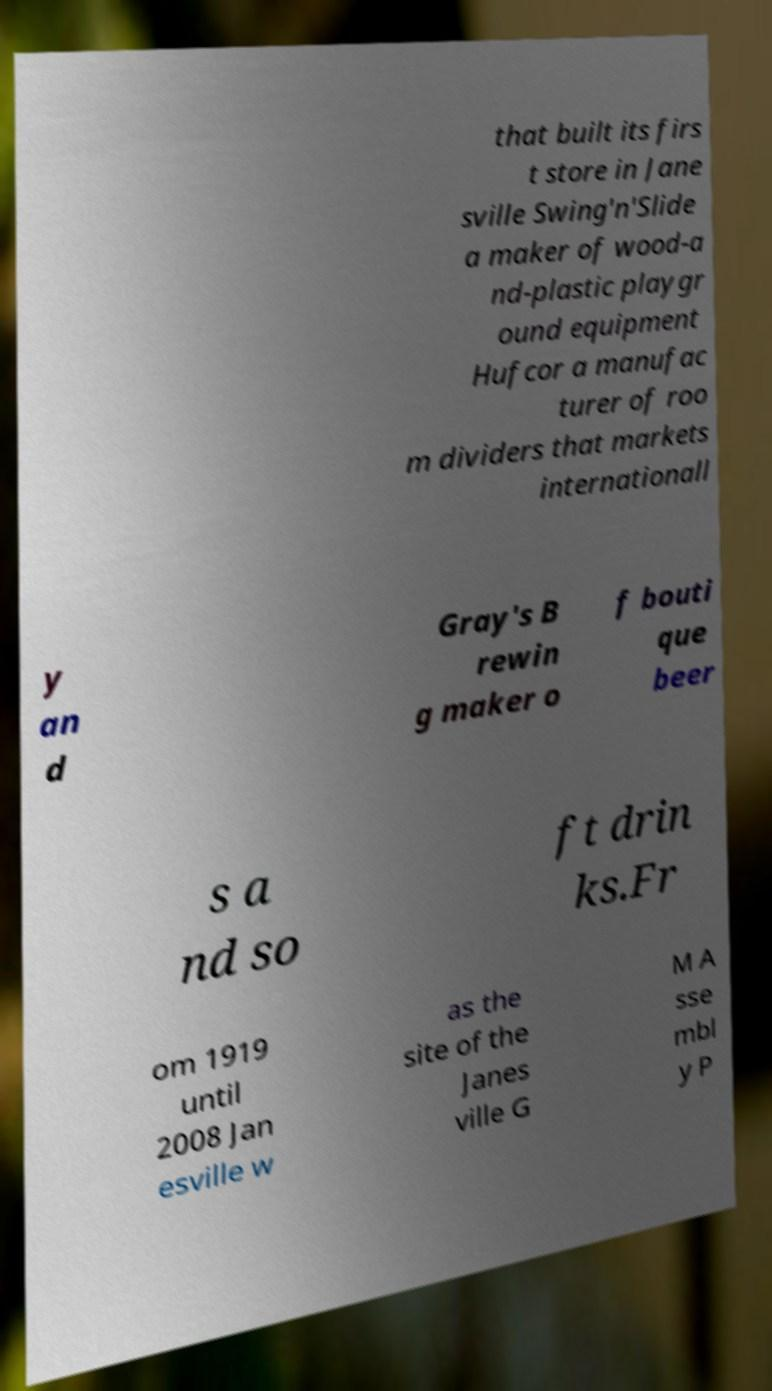For documentation purposes, I need the text within this image transcribed. Could you provide that? that built its firs t store in Jane sville Swing'n'Slide a maker of wood-a nd-plastic playgr ound equipment Hufcor a manufac turer of roo m dividers that markets internationall y an d Gray's B rewin g maker o f bouti que beer s a nd so ft drin ks.Fr om 1919 until 2008 Jan esville w as the site of the Janes ville G M A sse mbl y P 